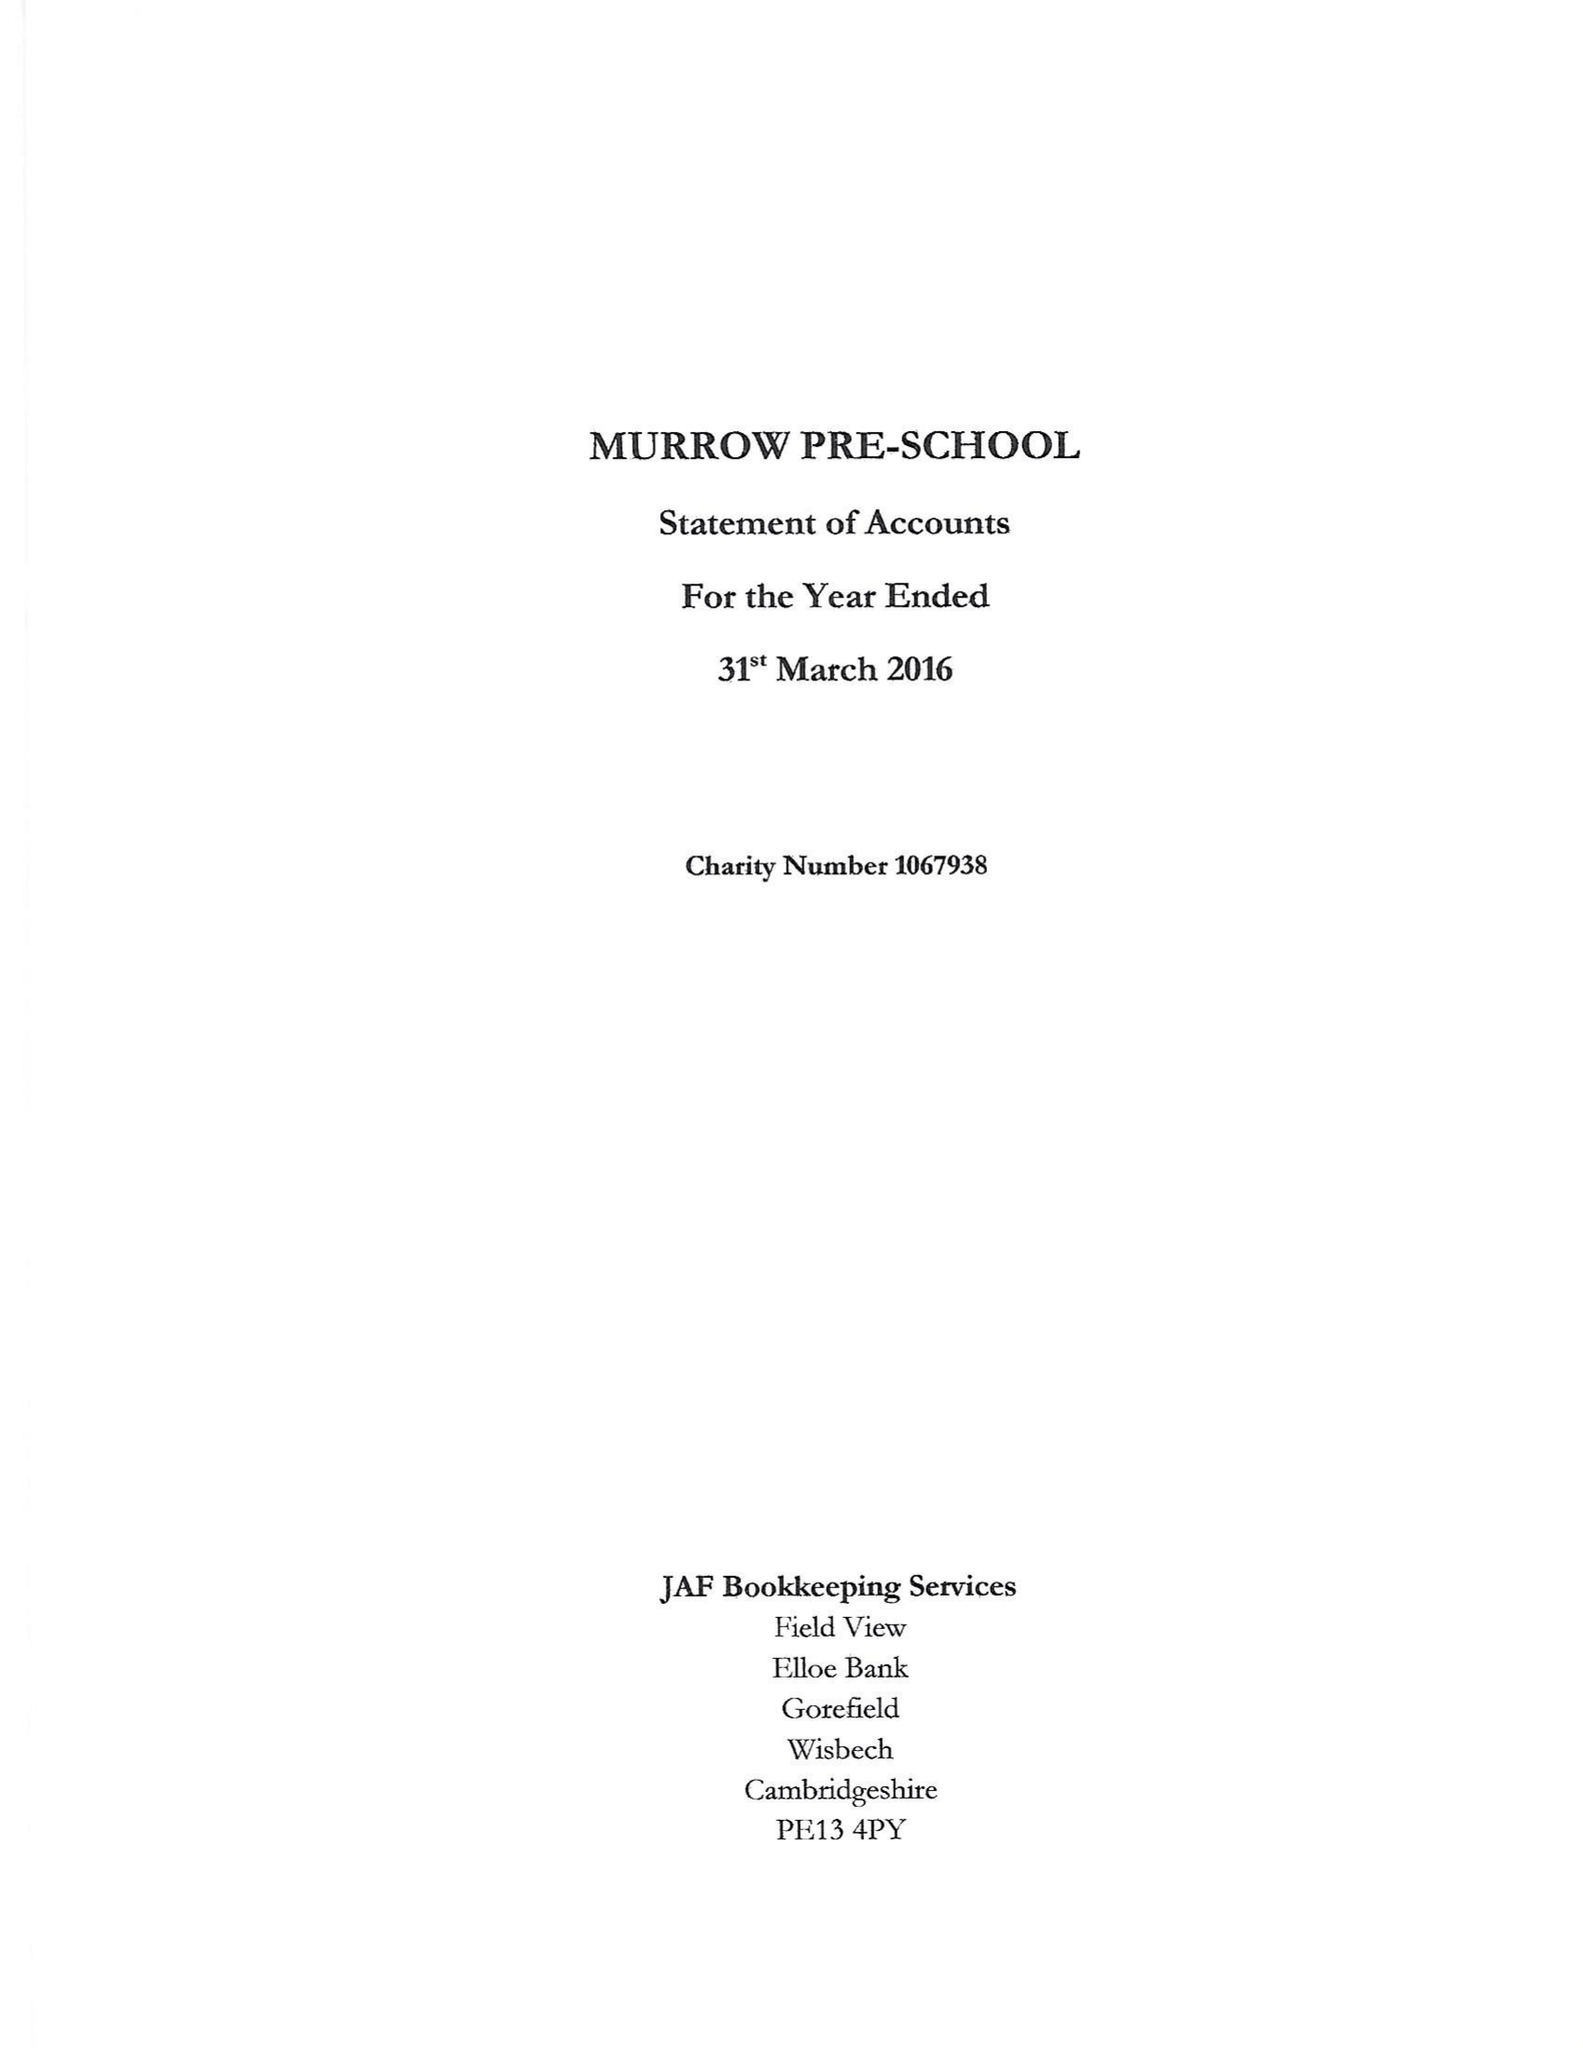What is the value for the income_annually_in_british_pounds?
Answer the question using a single word or phrase. 83611.00 